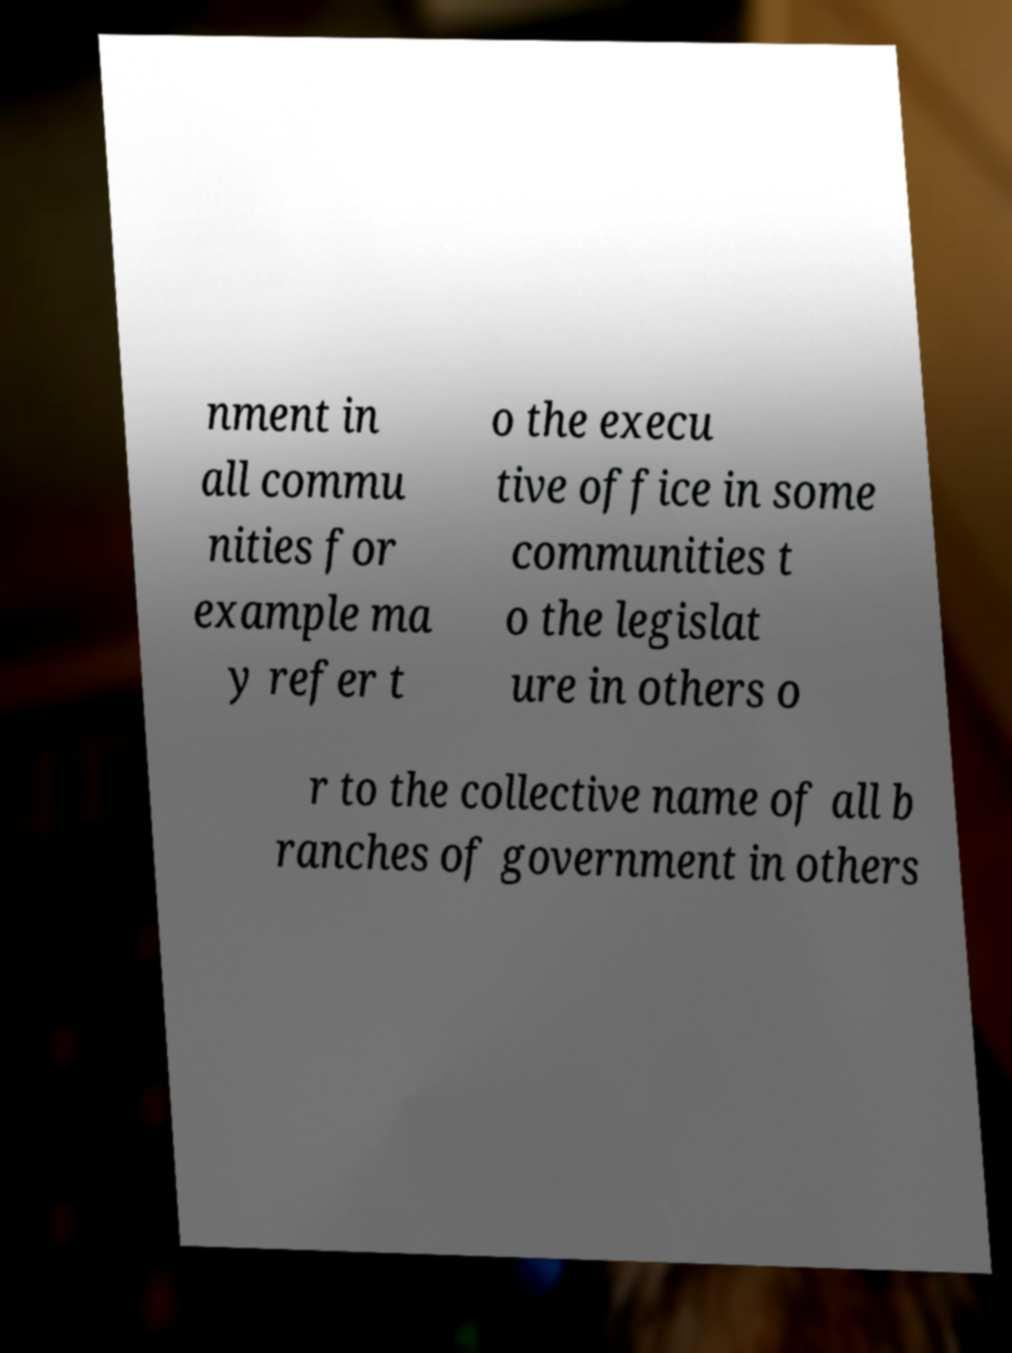There's text embedded in this image that I need extracted. Can you transcribe it verbatim? nment in all commu nities for example ma y refer t o the execu tive office in some communities t o the legislat ure in others o r to the collective name of all b ranches of government in others 